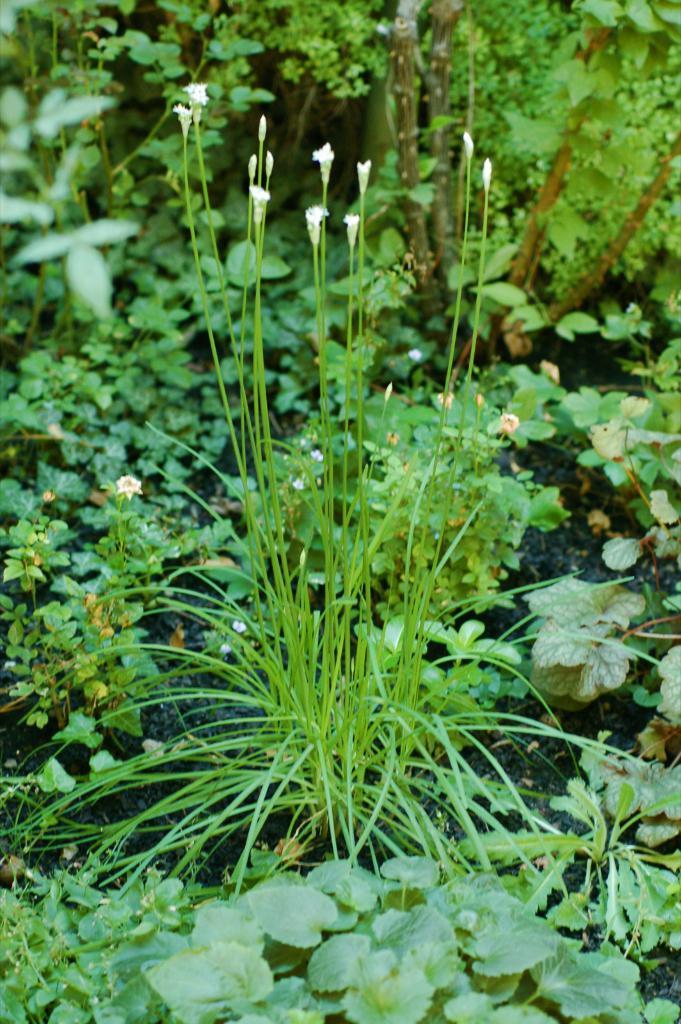In one or two sentences, can you explain what this image depicts? This is the picture of some white flowers to the trees and around there are some trees and plants. 